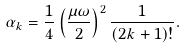Convert formula to latex. <formula><loc_0><loc_0><loc_500><loc_500>\alpha _ { k } = \frac { 1 } { 4 } \left ( \frac { \mu \omega } { 2 } \right ) ^ { 2 } \frac { 1 } { ( 2 k + 1 ) ! } .</formula> 